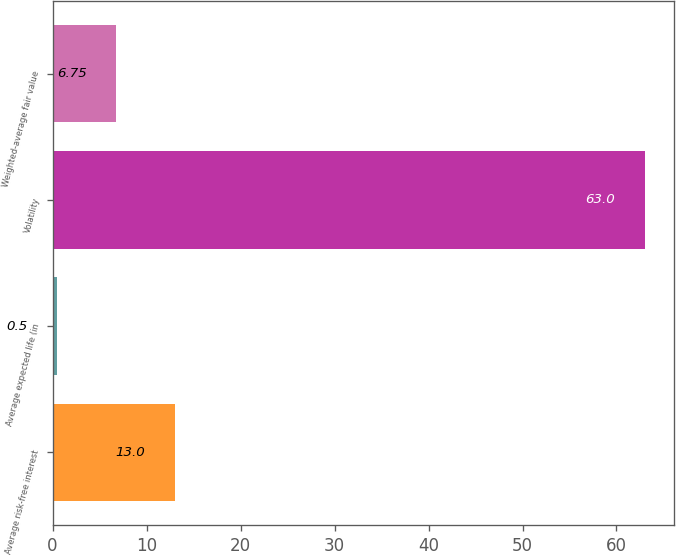<chart> <loc_0><loc_0><loc_500><loc_500><bar_chart><fcel>Average risk-free interest<fcel>Average expected life (in<fcel>Volatility<fcel>Weighted-average fair value<nl><fcel>13<fcel>0.5<fcel>63<fcel>6.75<nl></chart> 